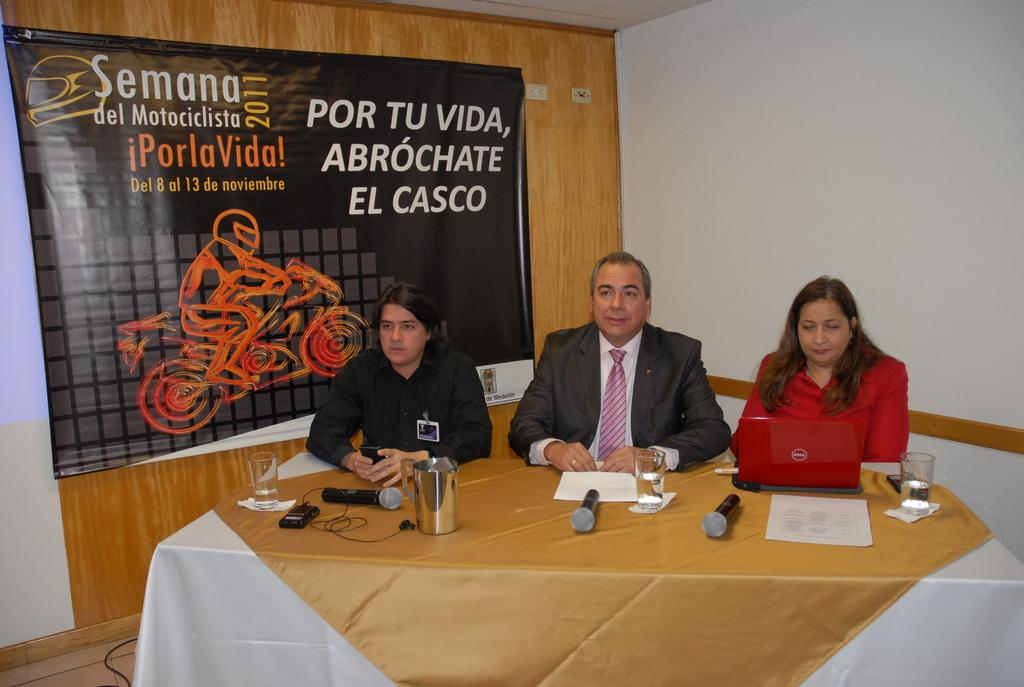What type of furniture is present in the image? There is a table in the image. What electronic devices can be seen in the image? There are microphones and a laptop in the image. What objects might be used for drinking in the image? There are glasses in the image. What type of people might be present in the image? There are people in the image. What architectural feature is visible in the image? There is a wall in the image. What type of signage is present in the image? There is a banner in the image. What color is the orange in the image? There is no orange present in the image. What type of guide is holding the microphone in the image? There is no guide present in the image, nor is there any indication of who might be holding the microphone. 